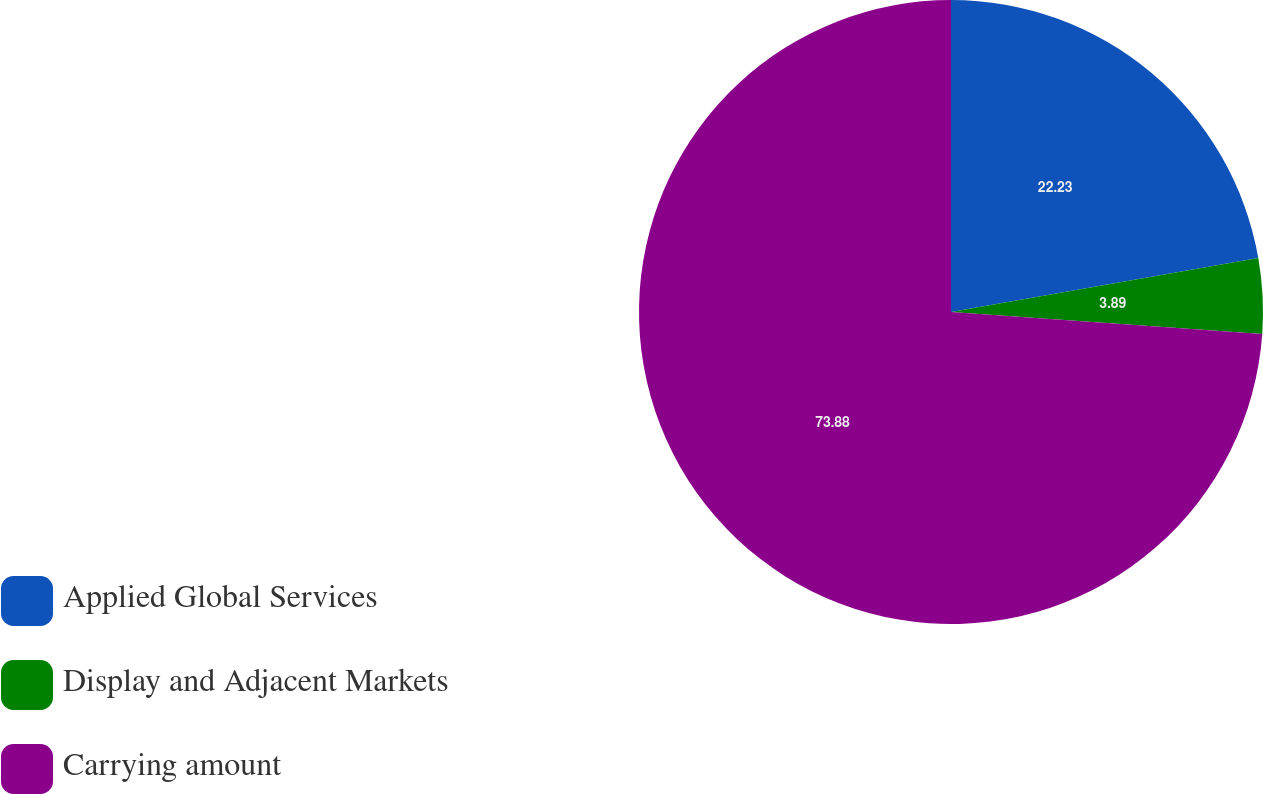Convert chart. <chart><loc_0><loc_0><loc_500><loc_500><pie_chart><fcel>Applied Global Services<fcel>Display and Adjacent Markets<fcel>Carrying amount<nl><fcel>22.23%<fcel>3.89%<fcel>73.88%<nl></chart> 